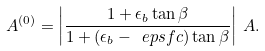Convert formula to latex. <formula><loc_0><loc_0><loc_500><loc_500>A ^ { ( 0 ) } = \left | \frac { 1 + \epsilon _ { b } \tan \beta } { 1 + ( \epsilon _ { b } - \ e p s f c ) \tan \beta } \right | \, A .</formula> 